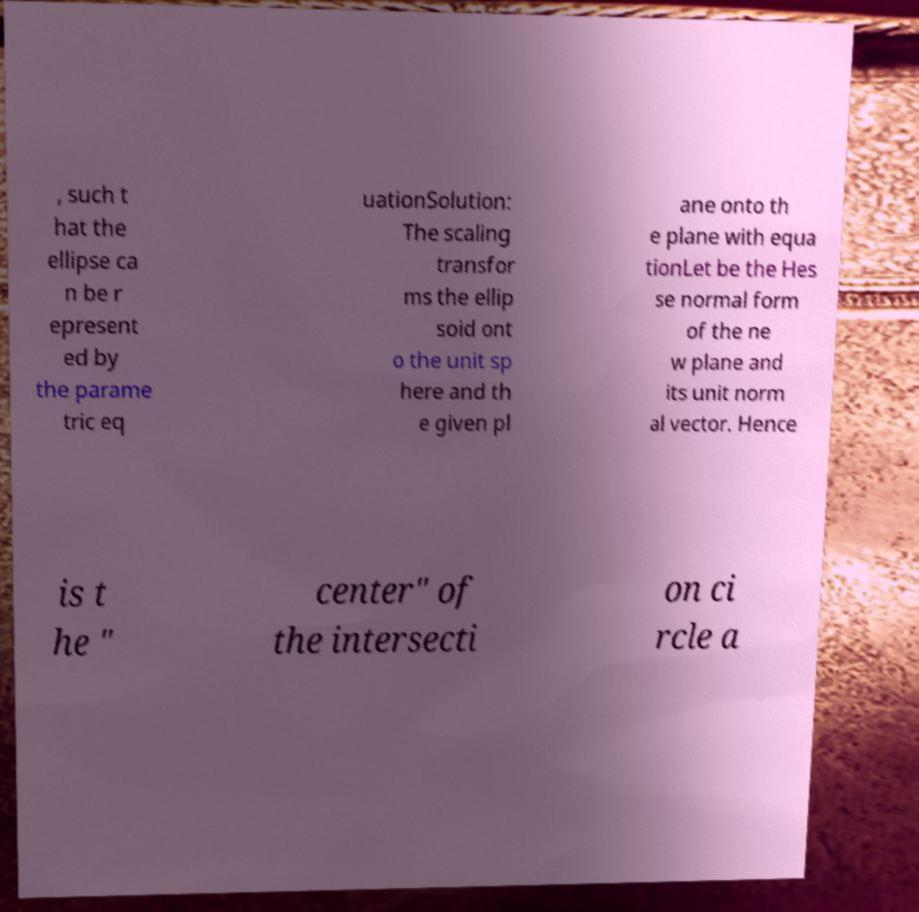Can you read and provide the text displayed in the image?This photo seems to have some interesting text. Can you extract and type it out for me? , such t hat the ellipse ca n be r epresent ed by the parame tric eq uationSolution: The scaling transfor ms the ellip soid ont o the unit sp here and th e given pl ane onto th e plane with equa tionLet be the Hes se normal form of the ne w plane and its unit norm al vector. Hence is t he " center" of the intersecti on ci rcle a 